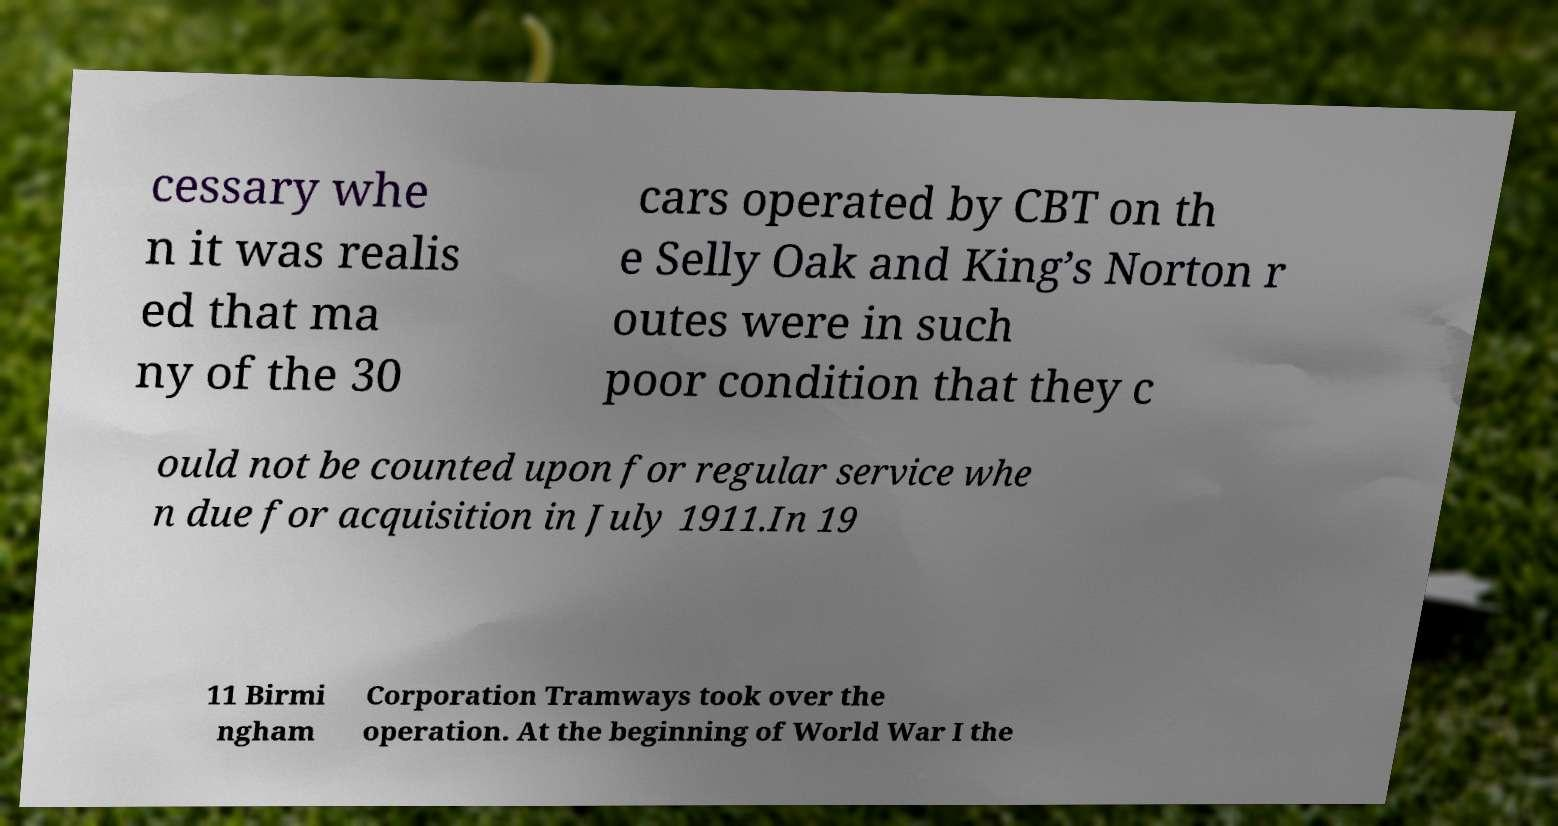Could you extract and type out the text from this image? cessary whe n it was realis ed that ma ny of the 30 cars operated by CBT on th e Selly Oak and King’s Norton r outes were in such poor condition that they c ould not be counted upon for regular service whe n due for acquisition in July 1911.In 19 11 Birmi ngham Corporation Tramways took over the operation. At the beginning of World War I the 